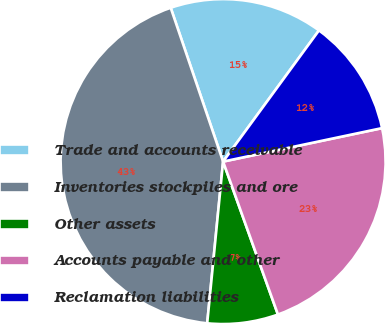Convert chart to OTSL. <chart><loc_0><loc_0><loc_500><loc_500><pie_chart><fcel>Trade and accounts receivable<fcel>Inventories stockpiles and ore<fcel>Other assets<fcel>Accounts payable and other<fcel>Reclamation liabilities<nl><fcel>15.27%<fcel>43.21%<fcel>7.04%<fcel>22.82%<fcel>11.65%<nl></chart> 